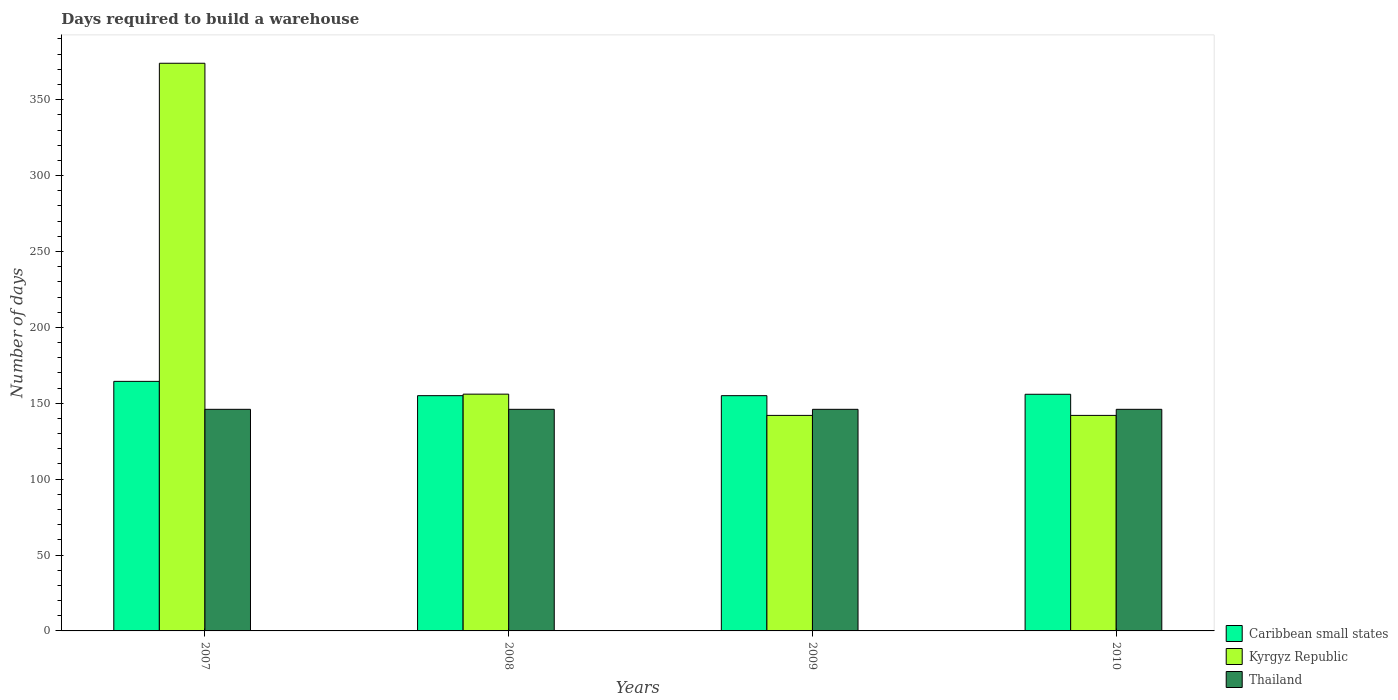How many different coloured bars are there?
Offer a very short reply. 3. How many groups of bars are there?
Offer a very short reply. 4. Are the number of bars per tick equal to the number of legend labels?
Keep it short and to the point. Yes. Are the number of bars on each tick of the X-axis equal?
Keep it short and to the point. Yes. How many bars are there on the 3rd tick from the left?
Your answer should be compact. 3. What is the label of the 2nd group of bars from the left?
Provide a short and direct response. 2008. What is the days required to build a warehouse in in Kyrgyz Republic in 2009?
Your answer should be compact. 142. Across all years, what is the maximum days required to build a warehouse in in Kyrgyz Republic?
Offer a very short reply. 374. Across all years, what is the minimum days required to build a warehouse in in Caribbean small states?
Keep it short and to the point. 155. In which year was the days required to build a warehouse in in Caribbean small states minimum?
Offer a very short reply. 2008. What is the total days required to build a warehouse in in Caribbean small states in the graph?
Your response must be concise. 630.33. What is the average days required to build a warehouse in in Kyrgyz Republic per year?
Ensure brevity in your answer.  203.5. In the year 2007, what is the difference between the days required to build a warehouse in in Thailand and days required to build a warehouse in in Caribbean small states?
Your response must be concise. -18.42. In how many years, is the days required to build a warehouse in in Kyrgyz Republic greater than 210 days?
Your answer should be compact. 1. What is the ratio of the days required to build a warehouse in in Kyrgyz Republic in 2009 to that in 2010?
Your answer should be very brief. 1. Is the difference between the days required to build a warehouse in in Thailand in 2008 and 2009 greater than the difference between the days required to build a warehouse in in Caribbean small states in 2008 and 2009?
Make the answer very short. No. What is the difference between the highest and the second highest days required to build a warehouse in in Caribbean small states?
Your answer should be very brief. 8.5. What is the difference between the highest and the lowest days required to build a warehouse in in Kyrgyz Republic?
Keep it short and to the point. 232. What does the 2nd bar from the left in 2009 represents?
Make the answer very short. Kyrgyz Republic. What does the 3rd bar from the right in 2007 represents?
Your answer should be very brief. Caribbean small states. Is it the case that in every year, the sum of the days required to build a warehouse in in Kyrgyz Republic and days required to build a warehouse in in Caribbean small states is greater than the days required to build a warehouse in in Thailand?
Make the answer very short. Yes. How many years are there in the graph?
Offer a very short reply. 4. Are the values on the major ticks of Y-axis written in scientific E-notation?
Your answer should be very brief. No. Does the graph contain any zero values?
Your answer should be compact. No. How many legend labels are there?
Your answer should be very brief. 3. How are the legend labels stacked?
Provide a short and direct response. Vertical. What is the title of the graph?
Keep it short and to the point. Days required to build a warehouse. Does "Malawi" appear as one of the legend labels in the graph?
Offer a terse response. No. What is the label or title of the X-axis?
Provide a succinct answer. Years. What is the label or title of the Y-axis?
Ensure brevity in your answer.  Number of days. What is the Number of days of Caribbean small states in 2007?
Keep it short and to the point. 164.42. What is the Number of days in Kyrgyz Republic in 2007?
Keep it short and to the point. 374. What is the Number of days in Thailand in 2007?
Your response must be concise. 146. What is the Number of days in Caribbean small states in 2008?
Make the answer very short. 155. What is the Number of days in Kyrgyz Republic in 2008?
Your answer should be very brief. 156. What is the Number of days in Thailand in 2008?
Make the answer very short. 146. What is the Number of days of Caribbean small states in 2009?
Your answer should be very brief. 155. What is the Number of days in Kyrgyz Republic in 2009?
Provide a short and direct response. 142. What is the Number of days of Thailand in 2009?
Provide a short and direct response. 146. What is the Number of days of Caribbean small states in 2010?
Your response must be concise. 155.92. What is the Number of days in Kyrgyz Republic in 2010?
Your answer should be very brief. 142. What is the Number of days in Thailand in 2010?
Your answer should be compact. 146. Across all years, what is the maximum Number of days in Caribbean small states?
Make the answer very short. 164.42. Across all years, what is the maximum Number of days of Kyrgyz Republic?
Your response must be concise. 374. Across all years, what is the maximum Number of days of Thailand?
Make the answer very short. 146. Across all years, what is the minimum Number of days in Caribbean small states?
Ensure brevity in your answer.  155. Across all years, what is the minimum Number of days in Kyrgyz Republic?
Your answer should be compact. 142. Across all years, what is the minimum Number of days of Thailand?
Offer a terse response. 146. What is the total Number of days in Caribbean small states in the graph?
Your response must be concise. 630.33. What is the total Number of days of Kyrgyz Republic in the graph?
Offer a terse response. 814. What is the total Number of days of Thailand in the graph?
Ensure brevity in your answer.  584. What is the difference between the Number of days in Caribbean small states in 2007 and that in 2008?
Provide a succinct answer. 9.42. What is the difference between the Number of days in Kyrgyz Republic in 2007 and that in 2008?
Keep it short and to the point. 218. What is the difference between the Number of days in Thailand in 2007 and that in 2008?
Give a very brief answer. 0. What is the difference between the Number of days of Caribbean small states in 2007 and that in 2009?
Provide a short and direct response. 9.42. What is the difference between the Number of days in Kyrgyz Republic in 2007 and that in 2009?
Offer a very short reply. 232. What is the difference between the Number of days of Thailand in 2007 and that in 2009?
Your answer should be compact. 0. What is the difference between the Number of days in Kyrgyz Republic in 2007 and that in 2010?
Provide a short and direct response. 232. What is the difference between the Number of days of Thailand in 2007 and that in 2010?
Provide a succinct answer. 0. What is the difference between the Number of days in Caribbean small states in 2008 and that in 2009?
Ensure brevity in your answer.  0. What is the difference between the Number of days of Kyrgyz Republic in 2008 and that in 2009?
Provide a succinct answer. 14. What is the difference between the Number of days in Caribbean small states in 2008 and that in 2010?
Ensure brevity in your answer.  -0.92. What is the difference between the Number of days in Caribbean small states in 2009 and that in 2010?
Give a very brief answer. -0.92. What is the difference between the Number of days of Kyrgyz Republic in 2009 and that in 2010?
Provide a short and direct response. 0. What is the difference between the Number of days of Thailand in 2009 and that in 2010?
Make the answer very short. 0. What is the difference between the Number of days in Caribbean small states in 2007 and the Number of days in Kyrgyz Republic in 2008?
Offer a terse response. 8.42. What is the difference between the Number of days of Caribbean small states in 2007 and the Number of days of Thailand in 2008?
Your answer should be compact. 18.42. What is the difference between the Number of days in Kyrgyz Republic in 2007 and the Number of days in Thailand in 2008?
Your answer should be very brief. 228. What is the difference between the Number of days of Caribbean small states in 2007 and the Number of days of Kyrgyz Republic in 2009?
Your answer should be compact. 22.42. What is the difference between the Number of days in Caribbean small states in 2007 and the Number of days in Thailand in 2009?
Give a very brief answer. 18.42. What is the difference between the Number of days of Kyrgyz Republic in 2007 and the Number of days of Thailand in 2009?
Offer a very short reply. 228. What is the difference between the Number of days in Caribbean small states in 2007 and the Number of days in Kyrgyz Republic in 2010?
Provide a succinct answer. 22.42. What is the difference between the Number of days in Caribbean small states in 2007 and the Number of days in Thailand in 2010?
Keep it short and to the point. 18.42. What is the difference between the Number of days of Kyrgyz Republic in 2007 and the Number of days of Thailand in 2010?
Your answer should be very brief. 228. What is the difference between the Number of days of Caribbean small states in 2008 and the Number of days of Kyrgyz Republic in 2009?
Your answer should be very brief. 13. What is the difference between the Number of days of Kyrgyz Republic in 2008 and the Number of days of Thailand in 2010?
Provide a succinct answer. 10. What is the difference between the Number of days in Caribbean small states in 2009 and the Number of days in Thailand in 2010?
Offer a very short reply. 9. What is the difference between the Number of days of Kyrgyz Republic in 2009 and the Number of days of Thailand in 2010?
Keep it short and to the point. -4. What is the average Number of days of Caribbean small states per year?
Offer a very short reply. 157.58. What is the average Number of days in Kyrgyz Republic per year?
Offer a very short reply. 203.5. What is the average Number of days of Thailand per year?
Ensure brevity in your answer.  146. In the year 2007, what is the difference between the Number of days in Caribbean small states and Number of days in Kyrgyz Republic?
Your answer should be compact. -209.58. In the year 2007, what is the difference between the Number of days of Caribbean small states and Number of days of Thailand?
Your answer should be compact. 18.42. In the year 2007, what is the difference between the Number of days of Kyrgyz Republic and Number of days of Thailand?
Offer a very short reply. 228. In the year 2008, what is the difference between the Number of days in Caribbean small states and Number of days in Thailand?
Offer a very short reply. 9. In the year 2009, what is the difference between the Number of days in Caribbean small states and Number of days in Kyrgyz Republic?
Offer a terse response. 13. In the year 2009, what is the difference between the Number of days of Caribbean small states and Number of days of Thailand?
Make the answer very short. 9. In the year 2009, what is the difference between the Number of days in Kyrgyz Republic and Number of days in Thailand?
Your answer should be very brief. -4. In the year 2010, what is the difference between the Number of days of Caribbean small states and Number of days of Kyrgyz Republic?
Provide a succinct answer. 13.92. In the year 2010, what is the difference between the Number of days of Caribbean small states and Number of days of Thailand?
Ensure brevity in your answer.  9.92. What is the ratio of the Number of days in Caribbean small states in 2007 to that in 2008?
Provide a short and direct response. 1.06. What is the ratio of the Number of days in Kyrgyz Republic in 2007 to that in 2008?
Provide a short and direct response. 2.4. What is the ratio of the Number of days of Thailand in 2007 to that in 2008?
Offer a very short reply. 1. What is the ratio of the Number of days in Caribbean small states in 2007 to that in 2009?
Your answer should be very brief. 1.06. What is the ratio of the Number of days of Kyrgyz Republic in 2007 to that in 2009?
Provide a succinct answer. 2.63. What is the ratio of the Number of days in Thailand in 2007 to that in 2009?
Provide a succinct answer. 1. What is the ratio of the Number of days of Caribbean small states in 2007 to that in 2010?
Provide a succinct answer. 1.05. What is the ratio of the Number of days in Kyrgyz Republic in 2007 to that in 2010?
Give a very brief answer. 2.63. What is the ratio of the Number of days of Caribbean small states in 2008 to that in 2009?
Offer a terse response. 1. What is the ratio of the Number of days of Kyrgyz Republic in 2008 to that in 2009?
Make the answer very short. 1.1. What is the ratio of the Number of days of Thailand in 2008 to that in 2009?
Provide a succinct answer. 1. What is the ratio of the Number of days of Kyrgyz Republic in 2008 to that in 2010?
Your answer should be very brief. 1.1. What is the ratio of the Number of days of Caribbean small states in 2009 to that in 2010?
Provide a succinct answer. 0.99. What is the ratio of the Number of days of Thailand in 2009 to that in 2010?
Give a very brief answer. 1. What is the difference between the highest and the second highest Number of days in Kyrgyz Republic?
Your response must be concise. 218. What is the difference between the highest and the lowest Number of days in Caribbean small states?
Keep it short and to the point. 9.42. What is the difference between the highest and the lowest Number of days of Kyrgyz Republic?
Your answer should be very brief. 232. 